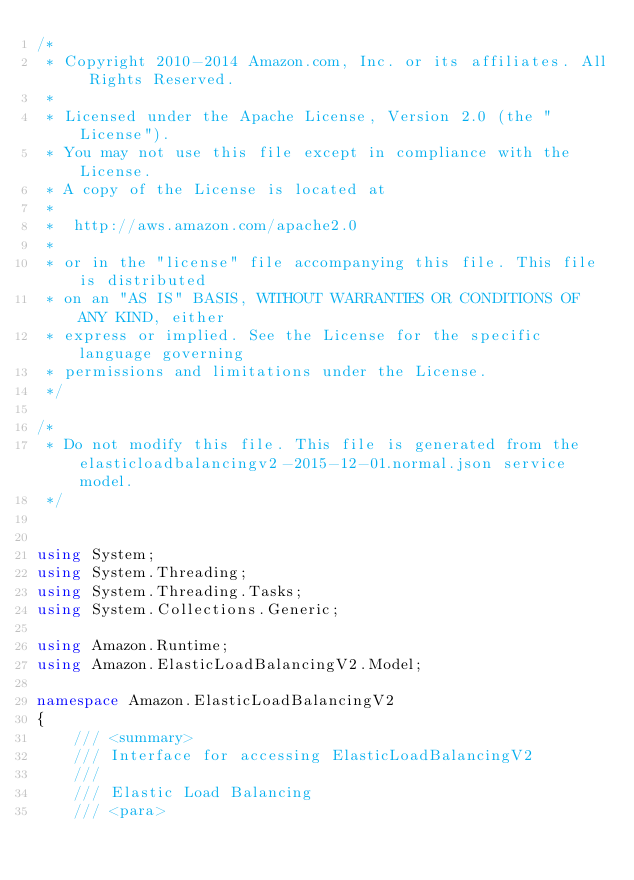<code> <loc_0><loc_0><loc_500><loc_500><_C#_>/*
 * Copyright 2010-2014 Amazon.com, Inc. or its affiliates. All Rights Reserved.
 * 
 * Licensed under the Apache License, Version 2.0 (the "License").
 * You may not use this file except in compliance with the License.
 * A copy of the License is located at
 * 
 *  http://aws.amazon.com/apache2.0
 * 
 * or in the "license" file accompanying this file. This file is distributed
 * on an "AS IS" BASIS, WITHOUT WARRANTIES OR CONDITIONS OF ANY KIND, either
 * express or implied. See the License for the specific language governing
 * permissions and limitations under the License.
 */

/*
 * Do not modify this file. This file is generated from the elasticloadbalancingv2-2015-12-01.normal.json service model.
 */


using System;
using System.Threading;
using System.Threading.Tasks;
using System.Collections.Generic;

using Amazon.Runtime;
using Amazon.ElasticLoadBalancingV2.Model;

namespace Amazon.ElasticLoadBalancingV2
{
    /// <summary>
    /// Interface for accessing ElasticLoadBalancingV2
    ///
    /// Elastic Load Balancing 
    /// <para></code> 